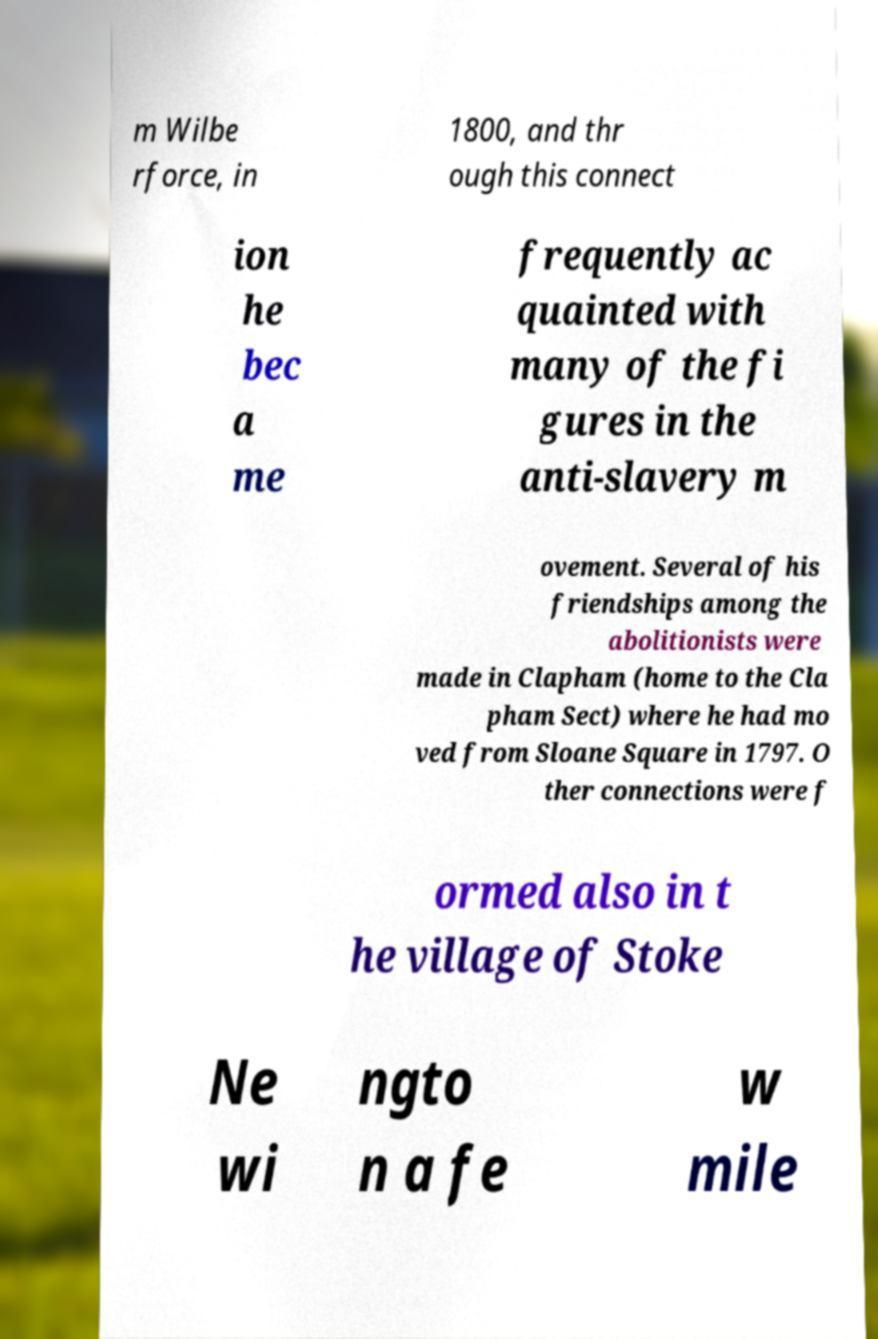Can you accurately transcribe the text from the provided image for me? m Wilbe rforce, in 1800, and thr ough this connect ion he bec a me frequently ac quainted with many of the fi gures in the anti-slavery m ovement. Several of his friendships among the abolitionists were made in Clapham (home to the Cla pham Sect) where he had mo ved from Sloane Square in 1797. O ther connections were f ormed also in t he village of Stoke Ne wi ngto n a fe w mile 